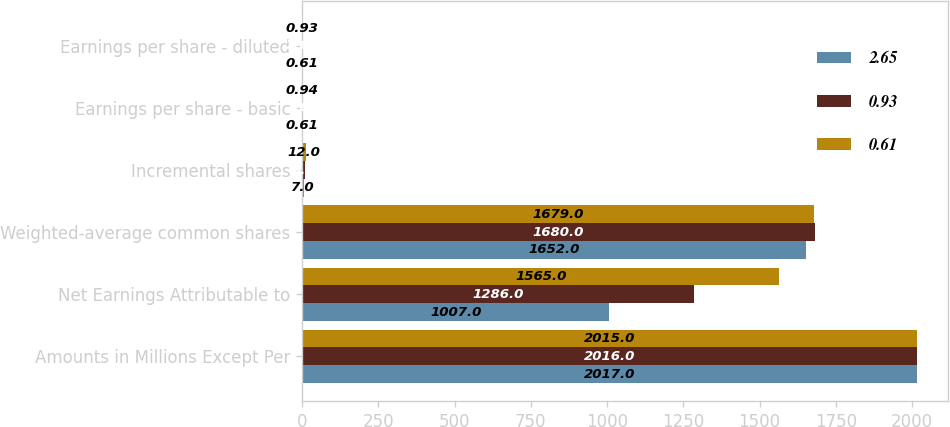Convert chart to OTSL. <chart><loc_0><loc_0><loc_500><loc_500><stacked_bar_chart><ecel><fcel>Amounts in Millions Except Per<fcel>Net Earnings Attributable to<fcel>Weighted-average common shares<fcel>Incremental shares<fcel>Earnings per share - basic<fcel>Earnings per share - diluted<nl><fcel>2.65<fcel>2017<fcel>1007<fcel>1652<fcel>7<fcel>0.61<fcel>0.61<nl><fcel>0.93<fcel>2016<fcel>1286<fcel>1680<fcel>9<fcel>2.67<fcel>2.65<nl><fcel>0.61<fcel>2015<fcel>1565<fcel>1679<fcel>12<fcel>0.94<fcel>0.93<nl></chart> 